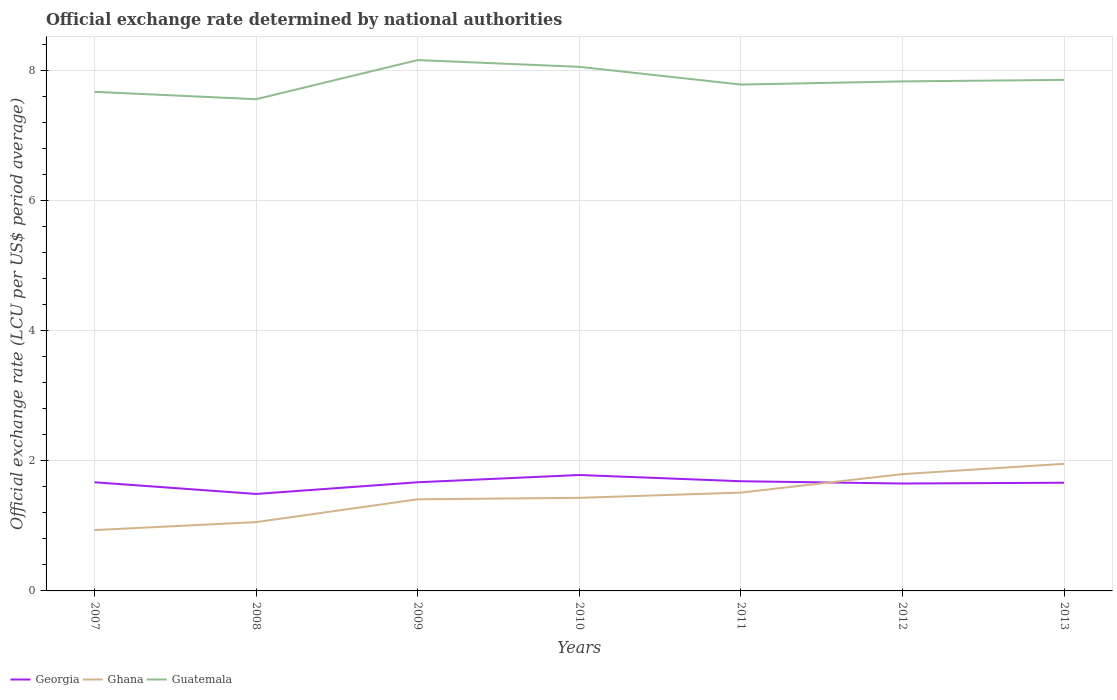How many different coloured lines are there?
Keep it short and to the point. 3. Across all years, what is the maximum official exchange rate in Georgia?
Your answer should be compact. 1.49. What is the total official exchange rate in Guatemala in the graph?
Give a very brief answer. -0.49. What is the difference between the highest and the second highest official exchange rate in Guatemala?
Keep it short and to the point. 0.6. How many lines are there?
Your answer should be compact. 3. How many years are there in the graph?
Keep it short and to the point. 7. Does the graph contain any zero values?
Your answer should be very brief. No. Does the graph contain grids?
Offer a terse response. Yes. How are the legend labels stacked?
Offer a terse response. Horizontal. What is the title of the graph?
Your response must be concise. Official exchange rate determined by national authorities. Does "El Salvador" appear as one of the legend labels in the graph?
Make the answer very short. No. What is the label or title of the Y-axis?
Give a very brief answer. Official exchange rate (LCU per US$ period average). What is the Official exchange rate (LCU per US$ period average) in Georgia in 2007?
Your response must be concise. 1.67. What is the Official exchange rate (LCU per US$ period average) of Ghana in 2007?
Offer a very short reply. 0.94. What is the Official exchange rate (LCU per US$ period average) of Guatemala in 2007?
Offer a terse response. 7.67. What is the Official exchange rate (LCU per US$ period average) of Georgia in 2008?
Offer a terse response. 1.49. What is the Official exchange rate (LCU per US$ period average) of Ghana in 2008?
Ensure brevity in your answer.  1.06. What is the Official exchange rate (LCU per US$ period average) of Guatemala in 2008?
Your response must be concise. 7.56. What is the Official exchange rate (LCU per US$ period average) of Georgia in 2009?
Provide a short and direct response. 1.67. What is the Official exchange rate (LCU per US$ period average) in Ghana in 2009?
Your answer should be very brief. 1.41. What is the Official exchange rate (LCU per US$ period average) of Guatemala in 2009?
Offer a very short reply. 8.16. What is the Official exchange rate (LCU per US$ period average) of Georgia in 2010?
Offer a terse response. 1.78. What is the Official exchange rate (LCU per US$ period average) in Ghana in 2010?
Provide a succinct answer. 1.43. What is the Official exchange rate (LCU per US$ period average) of Guatemala in 2010?
Make the answer very short. 8.06. What is the Official exchange rate (LCU per US$ period average) in Georgia in 2011?
Give a very brief answer. 1.69. What is the Official exchange rate (LCU per US$ period average) in Ghana in 2011?
Your response must be concise. 1.51. What is the Official exchange rate (LCU per US$ period average) in Guatemala in 2011?
Your answer should be very brief. 7.79. What is the Official exchange rate (LCU per US$ period average) of Georgia in 2012?
Make the answer very short. 1.65. What is the Official exchange rate (LCU per US$ period average) in Ghana in 2012?
Your answer should be very brief. 1.8. What is the Official exchange rate (LCU per US$ period average) in Guatemala in 2012?
Provide a short and direct response. 7.83. What is the Official exchange rate (LCU per US$ period average) in Georgia in 2013?
Make the answer very short. 1.66. What is the Official exchange rate (LCU per US$ period average) in Ghana in 2013?
Provide a short and direct response. 1.95. What is the Official exchange rate (LCU per US$ period average) of Guatemala in 2013?
Offer a very short reply. 7.86. Across all years, what is the maximum Official exchange rate (LCU per US$ period average) of Georgia?
Offer a very short reply. 1.78. Across all years, what is the maximum Official exchange rate (LCU per US$ period average) in Ghana?
Offer a terse response. 1.95. Across all years, what is the maximum Official exchange rate (LCU per US$ period average) in Guatemala?
Give a very brief answer. 8.16. Across all years, what is the minimum Official exchange rate (LCU per US$ period average) of Georgia?
Ensure brevity in your answer.  1.49. Across all years, what is the minimum Official exchange rate (LCU per US$ period average) in Ghana?
Ensure brevity in your answer.  0.94. Across all years, what is the minimum Official exchange rate (LCU per US$ period average) in Guatemala?
Offer a very short reply. 7.56. What is the total Official exchange rate (LCU per US$ period average) in Georgia in the graph?
Your answer should be compact. 11.62. What is the total Official exchange rate (LCU per US$ period average) in Ghana in the graph?
Offer a terse response. 10.09. What is the total Official exchange rate (LCU per US$ period average) of Guatemala in the graph?
Your answer should be compact. 54.93. What is the difference between the Official exchange rate (LCU per US$ period average) in Georgia in 2007 and that in 2008?
Your response must be concise. 0.18. What is the difference between the Official exchange rate (LCU per US$ period average) in Ghana in 2007 and that in 2008?
Your answer should be compact. -0.12. What is the difference between the Official exchange rate (LCU per US$ period average) in Guatemala in 2007 and that in 2008?
Your answer should be compact. 0.11. What is the difference between the Official exchange rate (LCU per US$ period average) in Georgia in 2007 and that in 2009?
Your answer should be very brief. 0. What is the difference between the Official exchange rate (LCU per US$ period average) in Ghana in 2007 and that in 2009?
Give a very brief answer. -0.47. What is the difference between the Official exchange rate (LCU per US$ period average) in Guatemala in 2007 and that in 2009?
Offer a terse response. -0.49. What is the difference between the Official exchange rate (LCU per US$ period average) in Georgia in 2007 and that in 2010?
Provide a short and direct response. -0.11. What is the difference between the Official exchange rate (LCU per US$ period average) of Ghana in 2007 and that in 2010?
Give a very brief answer. -0.5. What is the difference between the Official exchange rate (LCU per US$ period average) of Guatemala in 2007 and that in 2010?
Offer a terse response. -0.38. What is the difference between the Official exchange rate (LCU per US$ period average) of Georgia in 2007 and that in 2011?
Your answer should be compact. -0.02. What is the difference between the Official exchange rate (LCU per US$ period average) of Ghana in 2007 and that in 2011?
Your response must be concise. -0.58. What is the difference between the Official exchange rate (LCU per US$ period average) of Guatemala in 2007 and that in 2011?
Give a very brief answer. -0.11. What is the difference between the Official exchange rate (LCU per US$ period average) in Georgia in 2007 and that in 2012?
Make the answer very short. 0.02. What is the difference between the Official exchange rate (LCU per US$ period average) of Ghana in 2007 and that in 2012?
Ensure brevity in your answer.  -0.86. What is the difference between the Official exchange rate (LCU per US$ period average) of Guatemala in 2007 and that in 2012?
Ensure brevity in your answer.  -0.16. What is the difference between the Official exchange rate (LCU per US$ period average) in Georgia in 2007 and that in 2013?
Your answer should be compact. 0.01. What is the difference between the Official exchange rate (LCU per US$ period average) in Ghana in 2007 and that in 2013?
Provide a succinct answer. -1.02. What is the difference between the Official exchange rate (LCU per US$ period average) of Guatemala in 2007 and that in 2013?
Make the answer very short. -0.18. What is the difference between the Official exchange rate (LCU per US$ period average) of Georgia in 2008 and that in 2009?
Offer a very short reply. -0.18. What is the difference between the Official exchange rate (LCU per US$ period average) of Ghana in 2008 and that in 2009?
Offer a terse response. -0.35. What is the difference between the Official exchange rate (LCU per US$ period average) of Guatemala in 2008 and that in 2009?
Keep it short and to the point. -0.6. What is the difference between the Official exchange rate (LCU per US$ period average) in Georgia in 2008 and that in 2010?
Make the answer very short. -0.29. What is the difference between the Official exchange rate (LCU per US$ period average) in Ghana in 2008 and that in 2010?
Give a very brief answer. -0.37. What is the difference between the Official exchange rate (LCU per US$ period average) of Guatemala in 2008 and that in 2010?
Your answer should be very brief. -0.5. What is the difference between the Official exchange rate (LCU per US$ period average) in Georgia in 2008 and that in 2011?
Keep it short and to the point. -0.2. What is the difference between the Official exchange rate (LCU per US$ period average) of Ghana in 2008 and that in 2011?
Make the answer very short. -0.45. What is the difference between the Official exchange rate (LCU per US$ period average) in Guatemala in 2008 and that in 2011?
Your answer should be very brief. -0.23. What is the difference between the Official exchange rate (LCU per US$ period average) of Georgia in 2008 and that in 2012?
Provide a short and direct response. -0.16. What is the difference between the Official exchange rate (LCU per US$ period average) in Ghana in 2008 and that in 2012?
Provide a succinct answer. -0.74. What is the difference between the Official exchange rate (LCU per US$ period average) in Guatemala in 2008 and that in 2012?
Your response must be concise. -0.27. What is the difference between the Official exchange rate (LCU per US$ period average) in Georgia in 2008 and that in 2013?
Your answer should be compact. -0.17. What is the difference between the Official exchange rate (LCU per US$ period average) of Ghana in 2008 and that in 2013?
Provide a short and direct response. -0.9. What is the difference between the Official exchange rate (LCU per US$ period average) in Guatemala in 2008 and that in 2013?
Offer a terse response. -0.3. What is the difference between the Official exchange rate (LCU per US$ period average) in Georgia in 2009 and that in 2010?
Offer a terse response. -0.11. What is the difference between the Official exchange rate (LCU per US$ period average) in Ghana in 2009 and that in 2010?
Your answer should be compact. -0.02. What is the difference between the Official exchange rate (LCU per US$ period average) in Guatemala in 2009 and that in 2010?
Keep it short and to the point. 0.1. What is the difference between the Official exchange rate (LCU per US$ period average) in Georgia in 2009 and that in 2011?
Provide a succinct answer. -0.02. What is the difference between the Official exchange rate (LCU per US$ period average) of Ghana in 2009 and that in 2011?
Your answer should be compact. -0.1. What is the difference between the Official exchange rate (LCU per US$ period average) in Guatemala in 2009 and that in 2011?
Give a very brief answer. 0.38. What is the difference between the Official exchange rate (LCU per US$ period average) in Georgia in 2009 and that in 2012?
Give a very brief answer. 0.02. What is the difference between the Official exchange rate (LCU per US$ period average) in Ghana in 2009 and that in 2012?
Make the answer very short. -0.39. What is the difference between the Official exchange rate (LCU per US$ period average) of Guatemala in 2009 and that in 2012?
Keep it short and to the point. 0.33. What is the difference between the Official exchange rate (LCU per US$ period average) in Georgia in 2009 and that in 2013?
Provide a succinct answer. 0.01. What is the difference between the Official exchange rate (LCU per US$ period average) of Ghana in 2009 and that in 2013?
Offer a very short reply. -0.55. What is the difference between the Official exchange rate (LCU per US$ period average) of Guatemala in 2009 and that in 2013?
Provide a short and direct response. 0.3. What is the difference between the Official exchange rate (LCU per US$ period average) of Georgia in 2010 and that in 2011?
Provide a succinct answer. 0.1. What is the difference between the Official exchange rate (LCU per US$ period average) in Ghana in 2010 and that in 2011?
Provide a succinct answer. -0.08. What is the difference between the Official exchange rate (LCU per US$ period average) in Guatemala in 2010 and that in 2011?
Provide a short and direct response. 0.27. What is the difference between the Official exchange rate (LCU per US$ period average) in Georgia in 2010 and that in 2012?
Make the answer very short. 0.13. What is the difference between the Official exchange rate (LCU per US$ period average) of Ghana in 2010 and that in 2012?
Your response must be concise. -0.36. What is the difference between the Official exchange rate (LCU per US$ period average) of Guatemala in 2010 and that in 2012?
Offer a very short reply. 0.22. What is the difference between the Official exchange rate (LCU per US$ period average) of Georgia in 2010 and that in 2013?
Offer a terse response. 0.12. What is the difference between the Official exchange rate (LCU per US$ period average) in Ghana in 2010 and that in 2013?
Offer a terse response. -0.52. What is the difference between the Official exchange rate (LCU per US$ period average) of Guatemala in 2010 and that in 2013?
Offer a terse response. 0.2. What is the difference between the Official exchange rate (LCU per US$ period average) in Georgia in 2011 and that in 2012?
Your response must be concise. 0.04. What is the difference between the Official exchange rate (LCU per US$ period average) in Ghana in 2011 and that in 2012?
Your answer should be compact. -0.28. What is the difference between the Official exchange rate (LCU per US$ period average) of Guatemala in 2011 and that in 2012?
Make the answer very short. -0.05. What is the difference between the Official exchange rate (LCU per US$ period average) in Georgia in 2011 and that in 2013?
Offer a very short reply. 0.02. What is the difference between the Official exchange rate (LCU per US$ period average) in Ghana in 2011 and that in 2013?
Make the answer very short. -0.44. What is the difference between the Official exchange rate (LCU per US$ period average) in Guatemala in 2011 and that in 2013?
Ensure brevity in your answer.  -0.07. What is the difference between the Official exchange rate (LCU per US$ period average) in Georgia in 2012 and that in 2013?
Provide a succinct answer. -0.01. What is the difference between the Official exchange rate (LCU per US$ period average) in Ghana in 2012 and that in 2013?
Ensure brevity in your answer.  -0.16. What is the difference between the Official exchange rate (LCU per US$ period average) in Guatemala in 2012 and that in 2013?
Offer a very short reply. -0.02. What is the difference between the Official exchange rate (LCU per US$ period average) of Georgia in 2007 and the Official exchange rate (LCU per US$ period average) of Ghana in 2008?
Provide a succinct answer. 0.61. What is the difference between the Official exchange rate (LCU per US$ period average) in Georgia in 2007 and the Official exchange rate (LCU per US$ period average) in Guatemala in 2008?
Make the answer very short. -5.89. What is the difference between the Official exchange rate (LCU per US$ period average) in Ghana in 2007 and the Official exchange rate (LCU per US$ period average) in Guatemala in 2008?
Keep it short and to the point. -6.62. What is the difference between the Official exchange rate (LCU per US$ period average) in Georgia in 2007 and the Official exchange rate (LCU per US$ period average) in Ghana in 2009?
Offer a very short reply. 0.26. What is the difference between the Official exchange rate (LCU per US$ period average) in Georgia in 2007 and the Official exchange rate (LCU per US$ period average) in Guatemala in 2009?
Make the answer very short. -6.49. What is the difference between the Official exchange rate (LCU per US$ period average) in Ghana in 2007 and the Official exchange rate (LCU per US$ period average) in Guatemala in 2009?
Provide a short and direct response. -7.23. What is the difference between the Official exchange rate (LCU per US$ period average) in Georgia in 2007 and the Official exchange rate (LCU per US$ period average) in Ghana in 2010?
Provide a succinct answer. 0.24. What is the difference between the Official exchange rate (LCU per US$ period average) of Georgia in 2007 and the Official exchange rate (LCU per US$ period average) of Guatemala in 2010?
Provide a succinct answer. -6.39. What is the difference between the Official exchange rate (LCU per US$ period average) of Ghana in 2007 and the Official exchange rate (LCU per US$ period average) of Guatemala in 2010?
Offer a terse response. -7.12. What is the difference between the Official exchange rate (LCU per US$ period average) of Georgia in 2007 and the Official exchange rate (LCU per US$ period average) of Ghana in 2011?
Your answer should be very brief. 0.16. What is the difference between the Official exchange rate (LCU per US$ period average) of Georgia in 2007 and the Official exchange rate (LCU per US$ period average) of Guatemala in 2011?
Your answer should be very brief. -6.11. What is the difference between the Official exchange rate (LCU per US$ period average) of Ghana in 2007 and the Official exchange rate (LCU per US$ period average) of Guatemala in 2011?
Your answer should be very brief. -6.85. What is the difference between the Official exchange rate (LCU per US$ period average) of Georgia in 2007 and the Official exchange rate (LCU per US$ period average) of Ghana in 2012?
Your answer should be very brief. -0.13. What is the difference between the Official exchange rate (LCU per US$ period average) in Georgia in 2007 and the Official exchange rate (LCU per US$ period average) in Guatemala in 2012?
Your answer should be compact. -6.16. What is the difference between the Official exchange rate (LCU per US$ period average) in Ghana in 2007 and the Official exchange rate (LCU per US$ period average) in Guatemala in 2012?
Offer a terse response. -6.9. What is the difference between the Official exchange rate (LCU per US$ period average) in Georgia in 2007 and the Official exchange rate (LCU per US$ period average) in Ghana in 2013?
Offer a terse response. -0.28. What is the difference between the Official exchange rate (LCU per US$ period average) in Georgia in 2007 and the Official exchange rate (LCU per US$ period average) in Guatemala in 2013?
Make the answer very short. -6.19. What is the difference between the Official exchange rate (LCU per US$ period average) in Ghana in 2007 and the Official exchange rate (LCU per US$ period average) in Guatemala in 2013?
Your answer should be compact. -6.92. What is the difference between the Official exchange rate (LCU per US$ period average) of Georgia in 2008 and the Official exchange rate (LCU per US$ period average) of Ghana in 2009?
Keep it short and to the point. 0.08. What is the difference between the Official exchange rate (LCU per US$ period average) in Georgia in 2008 and the Official exchange rate (LCU per US$ period average) in Guatemala in 2009?
Make the answer very short. -6.67. What is the difference between the Official exchange rate (LCU per US$ period average) of Ghana in 2008 and the Official exchange rate (LCU per US$ period average) of Guatemala in 2009?
Offer a very short reply. -7.1. What is the difference between the Official exchange rate (LCU per US$ period average) of Georgia in 2008 and the Official exchange rate (LCU per US$ period average) of Ghana in 2010?
Give a very brief answer. 0.06. What is the difference between the Official exchange rate (LCU per US$ period average) of Georgia in 2008 and the Official exchange rate (LCU per US$ period average) of Guatemala in 2010?
Your response must be concise. -6.57. What is the difference between the Official exchange rate (LCU per US$ period average) in Ghana in 2008 and the Official exchange rate (LCU per US$ period average) in Guatemala in 2010?
Provide a short and direct response. -7. What is the difference between the Official exchange rate (LCU per US$ period average) of Georgia in 2008 and the Official exchange rate (LCU per US$ period average) of Ghana in 2011?
Give a very brief answer. -0.02. What is the difference between the Official exchange rate (LCU per US$ period average) in Georgia in 2008 and the Official exchange rate (LCU per US$ period average) in Guatemala in 2011?
Make the answer very short. -6.29. What is the difference between the Official exchange rate (LCU per US$ period average) in Ghana in 2008 and the Official exchange rate (LCU per US$ period average) in Guatemala in 2011?
Your response must be concise. -6.73. What is the difference between the Official exchange rate (LCU per US$ period average) of Georgia in 2008 and the Official exchange rate (LCU per US$ period average) of Ghana in 2012?
Offer a terse response. -0.3. What is the difference between the Official exchange rate (LCU per US$ period average) of Georgia in 2008 and the Official exchange rate (LCU per US$ period average) of Guatemala in 2012?
Make the answer very short. -6.34. What is the difference between the Official exchange rate (LCU per US$ period average) of Ghana in 2008 and the Official exchange rate (LCU per US$ period average) of Guatemala in 2012?
Your answer should be very brief. -6.78. What is the difference between the Official exchange rate (LCU per US$ period average) of Georgia in 2008 and the Official exchange rate (LCU per US$ period average) of Ghana in 2013?
Offer a terse response. -0.46. What is the difference between the Official exchange rate (LCU per US$ period average) of Georgia in 2008 and the Official exchange rate (LCU per US$ period average) of Guatemala in 2013?
Offer a terse response. -6.37. What is the difference between the Official exchange rate (LCU per US$ period average) of Ghana in 2008 and the Official exchange rate (LCU per US$ period average) of Guatemala in 2013?
Keep it short and to the point. -6.8. What is the difference between the Official exchange rate (LCU per US$ period average) of Georgia in 2009 and the Official exchange rate (LCU per US$ period average) of Ghana in 2010?
Provide a short and direct response. 0.24. What is the difference between the Official exchange rate (LCU per US$ period average) of Georgia in 2009 and the Official exchange rate (LCU per US$ period average) of Guatemala in 2010?
Your answer should be very brief. -6.39. What is the difference between the Official exchange rate (LCU per US$ period average) in Ghana in 2009 and the Official exchange rate (LCU per US$ period average) in Guatemala in 2010?
Provide a succinct answer. -6.65. What is the difference between the Official exchange rate (LCU per US$ period average) of Georgia in 2009 and the Official exchange rate (LCU per US$ period average) of Ghana in 2011?
Offer a very short reply. 0.16. What is the difference between the Official exchange rate (LCU per US$ period average) of Georgia in 2009 and the Official exchange rate (LCU per US$ period average) of Guatemala in 2011?
Your response must be concise. -6.11. What is the difference between the Official exchange rate (LCU per US$ period average) in Ghana in 2009 and the Official exchange rate (LCU per US$ period average) in Guatemala in 2011?
Your answer should be very brief. -6.38. What is the difference between the Official exchange rate (LCU per US$ period average) in Georgia in 2009 and the Official exchange rate (LCU per US$ period average) in Ghana in 2012?
Your response must be concise. -0.13. What is the difference between the Official exchange rate (LCU per US$ period average) of Georgia in 2009 and the Official exchange rate (LCU per US$ period average) of Guatemala in 2012?
Your answer should be very brief. -6.16. What is the difference between the Official exchange rate (LCU per US$ period average) in Ghana in 2009 and the Official exchange rate (LCU per US$ period average) in Guatemala in 2012?
Offer a terse response. -6.42. What is the difference between the Official exchange rate (LCU per US$ period average) of Georgia in 2009 and the Official exchange rate (LCU per US$ period average) of Ghana in 2013?
Make the answer very short. -0.28. What is the difference between the Official exchange rate (LCU per US$ period average) of Georgia in 2009 and the Official exchange rate (LCU per US$ period average) of Guatemala in 2013?
Keep it short and to the point. -6.19. What is the difference between the Official exchange rate (LCU per US$ period average) of Ghana in 2009 and the Official exchange rate (LCU per US$ period average) of Guatemala in 2013?
Provide a short and direct response. -6.45. What is the difference between the Official exchange rate (LCU per US$ period average) of Georgia in 2010 and the Official exchange rate (LCU per US$ period average) of Ghana in 2011?
Your answer should be compact. 0.27. What is the difference between the Official exchange rate (LCU per US$ period average) in Georgia in 2010 and the Official exchange rate (LCU per US$ period average) in Guatemala in 2011?
Your response must be concise. -6. What is the difference between the Official exchange rate (LCU per US$ period average) of Ghana in 2010 and the Official exchange rate (LCU per US$ period average) of Guatemala in 2011?
Your answer should be compact. -6.35. What is the difference between the Official exchange rate (LCU per US$ period average) of Georgia in 2010 and the Official exchange rate (LCU per US$ period average) of Ghana in 2012?
Your response must be concise. -0.01. What is the difference between the Official exchange rate (LCU per US$ period average) in Georgia in 2010 and the Official exchange rate (LCU per US$ period average) in Guatemala in 2012?
Provide a succinct answer. -6.05. What is the difference between the Official exchange rate (LCU per US$ period average) of Ghana in 2010 and the Official exchange rate (LCU per US$ period average) of Guatemala in 2012?
Offer a very short reply. -6.4. What is the difference between the Official exchange rate (LCU per US$ period average) of Georgia in 2010 and the Official exchange rate (LCU per US$ period average) of Ghana in 2013?
Your response must be concise. -0.17. What is the difference between the Official exchange rate (LCU per US$ period average) of Georgia in 2010 and the Official exchange rate (LCU per US$ period average) of Guatemala in 2013?
Make the answer very short. -6.07. What is the difference between the Official exchange rate (LCU per US$ period average) in Ghana in 2010 and the Official exchange rate (LCU per US$ period average) in Guatemala in 2013?
Your answer should be compact. -6.43. What is the difference between the Official exchange rate (LCU per US$ period average) in Georgia in 2011 and the Official exchange rate (LCU per US$ period average) in Ghana in 2012?
Your answer should be compact. -0.11. What is the difference between the Official exchange rate (LCU per US$ period average) in Georgia in 2011 and the Official exchange rate (LCU per US$ period average) in Guatemala in 2012?
Offer a terse response. -6.15. What is the difference between the Official exchange rate (LCU per US$ period average) in Ghana in 2011 and the Official exchange rate (LCU per US$ period average) in Guatemala in 2012?
Provide a succinct answer. -6.32. What is the difference between the Official exchange rate (LCU per US$ period average) of Georgia in 2011 and the Official exchange rate (LCU per US$ period average) of Ghana in 2013?
Provide a short and direct response. -0.27. What is the difference between the Official exchange rate (LCU per US$ period average) in Georgia in 2011 and the Official exchange rate (LCU per US$ period average) in Guatemala in 2013?
Your answer should be compact. -6.17. What is the difference between the Official exchange rate (LCU per US$ period average) in Ghana in 2011 and the Official exchange rate (LCU per US$ period average) in Guatemala in 2013?
Offer a terse response. -6.34. What is the difference between the Official exchange rate (LCU per US$ period average) in Georgia in 2012 and the Official exchange rate (LCU per US$ period average) in Ghana in 2013?
Offer a very short reply. -0.3. What is the difference between the Official exchange rate (LCU per US$ period average) of Georgia in 2012 and the Official exchange rate (LCU per US$ period average) of Guatemala in 2013?
Offer a terse response. -6.21. What is the difference between the Official exchange rate (LCU per US$ period average) of Ghana in 2012 and the Official exchange rate (LCU per US$ period average) of Guatemala in 2013?
Offer a terse response. -6.06. What is the average Official exchange rate (LCU per US$ period average) in Georgia per year?
Your answer should be compact. 1.66. What is the average Official exchange rate (LCU per US$ period average) of Ghana per year?
Provide a short and direct response. 1.44. What is the average Official exchange rate (LCU per US$ period average) in Guatemala per year?
Ensure brevity in your answer.  7.85. In the year 2007, what is the difference between the Official exchange rate (LCU per US$ period average) of Georgia and Official exchange rate (LCU per US$ period average) of Ghana?
Your response must be concise. 0.74. In the year 2007, what is the difference between the Official exchange rate (LCU per US$ period average) in Georgia and Official exchange rate (LCU per US$ period average) in Guatemala?
Give a very brief answer. -6. In the year 2007, what is the difference between the Official exchange rate (LCU per US$ period average) in Ghana and Official exchange rate (LCU per US$ period average) in Guatemala?
Provide a succinct answer. -6.74. In the year 2008, what is the difference between the Official exchange rate (LCU per US$ period average) in Georgia and Official exchange rate (LCU per US$ period average) in Ghana?
Offer a terse response. 0.43. In the year 2008, what is the difference between the Official exchange rate (LCU per US$ period average) in Georgia and Official exchange rate (LCU per US$ period average) in Guatemala?
Keep it short and to the point. -6.07. In the year 2008, what is the difference between the Official exchange rate (LCU per US$ period average) of Ghana and Official exchange rate (LCU per US$ period average) of Guatemala?
Keep it short and to the point. -6.5. In the year 2009, what is the difference between the Official exchange rate (LCU per US$ period average) of Georgia and Official exchange rate (LCU per US$ period average) of Ghana?
Your answer should be compact. 0.26. In the year 2009, what is the difference between the Official exchange rate (LCU per US$ period average) in Georgia and Official exchange rate (LCU per US$ period average) in Guatemala?
Give a very brief answer. -6.49. In the year 2009, what is the difference between the Official exchange rate (LCU per US$ period average) of Ghana and Official exchange rate (LCU per US$ period average) of Guatemala?
Offer a very short reply. -6.75. In the year 2010, what is the difference between the Official exchange rate (LCU per US$ period average) in Georgia and Official exchange rate (LCU per US$ period average) in Ghana?
Your response must be concise. 0.35. In the year 2010, what is the difference between the Official exchange rate (LCU per US$ period average) of Georgia and Official exchange rate (LCU per US$ period average) of Guatemala?
Offer a very short reply. -6.28. In the year 2010, what is the difference between the Official exchange rate (LCU per US$ period average) in Ghana and Official exchange rate (LCU per US$ period average) in Guatemala?
Your answer should be very brief. -6.63. In the year 2011, what is the difference between the Official exchange rate (LCU per US$ period average) of Georgia and Official exchange rate (LCU per US$ period average) of Ghana?
Your answer should be very brief. 0.17. In the year 2011, what is the difference between the Official exchange rate (LCU per US$ period average) in Georgia and Official exchange rate (LCU per US$ period average) in Guatemala?
Provide a succinct answer. -6.1. In the year 2011, what is the difference between the Official exchange rate (LCU per US$ period average) in Ghana and Official exchange rate (LCU per US$ period average) in Guatemala?
Keep it short and to the point. -6.27. In the year 2012, what is the difference between the Official exchange rate (LCU per US$ period average) of Georgia and Official exchange rate (LCU per US$ period average) of Ghana?
Ensure brevity in your answer.  -0.14. In the year 2012, what is the difference between the Official exchange rate (LCU per US$ period average) of Georgia and Official exchange rate (LCU per US$ period average) of Guatemala?
Your response must be concise. -6.18. In the year 2012, what is the difference between the Official exchange rate (LCU per US$ period average) of Ghana and Official exchange rate (LCU per US$ period average) of Guatemala?
Your answer should be compact. -6.04. In the year 2013, what is the difference between the Official exchange rate (LCU per US$ period average) of Georgia and Official exchange rate (LCU per US$ period average) of Ghana?
Offer a terse response. -0.29. In the year 2013, what is the difference between the Official exchange rate (LCU per US$ period average) of Georgia and Official exchange rate (LCU per US$ period average) of Guatemala?
Your response must be concise. -6.19. In the year 2013, what is the difference between the Official exchange rate (LCU per US$ period average) of Ghana and Official exchange rate (LCU per US$ period average) of Guatemala?
Ensure brevity in your answer.  -5.9. What is the ratio of the Official exchange rate (LCU per US$ period average) of Georgia in 2007 to that in 2008?
Provide a succinct answer. 1.12. What is the ratio of the Official exchange rate (LCU per US$ period average) in Ghana in 2007 to that in 2008?
Your answer should be very brief. 0.88. What is the ratio of the Official exchange rate (LCU per US$ period average) in Guatemala in 2007 to that in 2008?
Your response must be concise. 1.01. What is the ratio of the Official exchange rate (LCU per US$ period average) in Ghana in 2007 to that in 2009?
Your answer should be compact. 0.66. What is the ratio of the Official exchange rate (LCU per US$ period average) of Guatemala in 2007 to that in 2009?
Provide a succinct answer. 0.94. What is the ratio of the Official exchange rate (LCU per US$ period average) in Georgia in 2007 to that in 2010?
Keep it short and to the point. 0.94. What is the ratio of the Official exchange rate (LCU per US$ period average) in Ghana in 2007 to that in 2010?
Make the answer very short. 0.65. What is the ratio of the Official exchange rate (LCU per US$ period average) in Guatemala in 2007 to that in 2010?
Provide a short and direct response. 0.95. What is the ratio of the Official exchange rate (LCU per US$ period average) in Ghana in 2007 to that in 2011?
Your answer should be compact. 0.62. What is the ratio of the Official exchange rate (LCU per US$ period average) in Guatemala in 2007 to that in 2011?
Offer a very short reply. 0.99. What is the ratio of the Official exchange rate (LCU per US$ period average) in Georgia in 2007 to that in 2012?
Provide a short and direct response. 1.01. What is the ratio of the Official exchange rate (LCU per US$ period average) in Ghana in 2007 to that in 2012?
Your answer should be very brief. 0.52. What is the ratio of the Official exchange rate (LCU per US$ period average) in Guatemala in 2007 to that in 2012?
Give a very brief answer. 0.98. What is the ratio of the Official exchange rate (LCU per US$ period average) in Georgia in 2007 to that in 2013?
Keep it short and to the point. 1. What is the ratio of the Official exchange rate (LCU per US$ period average) of Ghana in 2007 to that in 2013?
Offer a very short reply. 0.48. What is the ratio of the Official exchange rate (LCU per US$ period average) of Guatemala in 2007 to that in 2013?
Provide a succinct answer. 0.98. What is the ratio of the Official exchange rate (LCU per US$ period average) of Georgia in 2008 to that in 2009?
Your answer should be very brief. 0.89. What is the ratio of the Official exchange rate (LCU per US$ period average) of Ghana in 2008 to that in 2009?
Keep it short and to the point. 0.75. What is the ratio of the Official exchange rate (LCU per US$ period average) in Guatemala in 2008 to that in 2009?
Give a very brief answer. 0.93. What is the ratio of the Official exchange rate (LCU per US$ period average) in Georgia in 2008 to that in 2010?
Ensure brevity in your answer.  0.84. What is the ratio of the Official exchange rate (LCU per US$ period average) in Ghana in 2008 to that in 2010?
Your answer should be compact. 0.74. What is the ratio of the Official exchange rate (LCU per US$ period average) in Guatemala in 2008 to that in 2010?
Your answer should be very brief. 0.94. What is the ratio of the Official exchange rate (LCU per US$ period average) of Georgia in 2008 to that in 2011?
Your answer should be compact. 0.88. What is the ratio of the Official exchange rate (LCU per US$ period average) in Ghana in 2008 to that in 2011?
Give a very brief answer. 0.7. What is the ratio of the Official exchange rate (LCU per US$ period average) in Georgia in 2008 to that in 2012?
Your answer should be compact. 0.9. What is the ratio of the Official exchange rate (LCU per US$ period average) of Ghana in 2008 to that in 2012?
Your answer should be compact. 0.59. What is the ratio of the Official exchange rate (LCU per US$ period average) of Guatemala in 2008 to that in 2012?
Make the answer very short. 0.97. What is the ratio of the Official exchange rate (LCU per US$ period average) in Georgia in 2008 to that in 2013?
Your answer should be very brief. 0.9. What is the ratio of the Official exchange rate (LCU per US$ period average) of Ghana in 2008 to that in 2013?
Offer a very short reply. 0.54. What is the ratio of the Official exchange rate (LCU per US$ period average) of Guatemala in 2008 to that in 2013?
Provide a short and direct response. 0.96. What is the ratio of the Official exchange rate (LCU per US$ period average) of Georgia in 2009 to that in 2010?
Keep it short and to the point. 0.94. What is the ratio of the Official exchange rate (LCU per US$ period average) of Ghana in 2009 to that in 2010?
Your answer should be very brief. 0.98. What is the ratio of the Official exchange rate (LCU per US$ period average) in Guatemala in 2009 to that in 2010?
Offer a very short reply. 1.01. What is the ratio of the Official exchange rate (LCU per US$ period average) of Ghana in 2009 to that in 2011?
Your response must be concise. 0.93. What is the ratio of the Official exchange rate (LCU per US$ period average) of Guatemala in 2009 to that in 2011?
Provide a short and direct response. 1.05. What is the ratio of the Official exchange rate (LCU per US$ period average) in Georgia in 2009 to that in 2012?
Your response must be concise. 1.01. What is the ratio of the Official exchange rate (LCU per US$ period average) in Ghana in 2009 to that in 2012?
Offer a very short reply. 0.78. What is the ratio of the Official exchange rate (LCU per US$ period average) in Guatemala in 2009 to that in 2012?
Make the answer very short. 1.04. What is the ratio of the Official exchange rate (LCU per US$ period average) of Ghana in 2009 to that in 2013?
Make the answer very short. 0.72. What is the ratio of the Official exchange rate (LCU per US$ period average) of Guatemala in 2009 to that in 2013?
Provide a succinct answer. 1.04. What is the ratio of the Official exchange rate (LCU per US$ period average) of Georgia in 2010 to that in 2011?
Ensure brevity in your answer.  1.06. What is the ratio of the Official exchange rate (LCU per US$ period average) in Ghana in 2010 to that in 2011?
Your answer should be compact. 0.95. What is the ratio of the Official exchange rate (LCU per US$ period average) of Guatemala in 2010 to that in 2011?
Make the answer very short. 1.03. What is the ratio of the Official exchange rate (LCU per US$ period average) of Georgia in 2010 to that in 2012?
Keep it short and to the point. 1.08. What is the ratio of the Official exchange rate (LCU per US$ period average) of Ghana in 2010 to that in 2012?
Offer a terse response. 0.8. What is the ratio of the Official exchange rate (LCU per US$ period average) in Guatemala in 2010 to that in 2012?
Ensure brevity in your answer.  1.03. What is the ratio of the Official exchange rate (LCU per US$ period average) in Georgia in 2010 to that in 2013?
Your answer should be very brief. 1.07. What is the ratio of the Official exchange rate (LCU per US$ period average) of Ghana in 2010 to that in 2013?
Offer a very short reply. 0.73. What is the ratio of the Official exchange rate (LCU per US$ period average) of Guatemala in 2010 to that in 2013?
Offer a very short reply. 1.03. What is the ratio of the Official exchange rate (LCU per US$ period average) of Georgia in 2011 to that in 2012?
Offer a terse response. 1.02. What is the ratio of the Official exchange rate (LCU per US$ period average) in Ghana in 2011 to that in 2012?
Keep it short and to the point. 0.84. What is the ratio of the Official exchange rate (LCU per US$ period average) of Guatemala in 2011 to that in 2012?
Offer a terse response. 0.99. What is the ratio of the Official exchange rate (LCU per US$ period average) in Georgia in 2011 to that in 2013?
Your response must be concise. 1.01. What is the ratio of the Official exchange rate (LCU per US$ period average) in Ghana in 2011 to that in 2013?
Make the answer very short. 0.77. What is the ratio of the Official exchange rate (LCU per US$ period average) in Guatemala in 2011 to that in 2013?
Your response must be concise. 0.99. What is the ratio of the Official exchange rate (LCU per US$ period average) of Ghana in 2012 to that in 2013?
Provide a short and direct response. 0.92. What is the ratio of the Official exchange rate (LCU per US$ period average) of Guatemala in 2012 to that in 2013?
Provide a short and direct response. 1. What is the difference between the highest and the second highest Official exchange rate (LCU per US$ period average) of Georgia?
Make the answer very short. 0.1. What is the difference between the highest and the second highest Official exchange rate (LCU per US$ period average) of Ghana?
Provide a succinct answer. 0.16. What is the difference between the highest and the second highest Official exchange rate (LCU per US$ period average) of Guatemala?
Offer a terse response. 0.1. What is the difference between the highest and the lowest Official exchange rate (LCU per US$ period average) in Georgia?
Keep it short and to the point. 0.29. What is the difference between the highest and the lowest Official exchange rate (LCU per US$ period average) of Ghana?
Make the answer very short. 1.02. What is the difference between the highest and the lowest Official exchange rate (LCU per US$ period average) in Guatemala?
Ensure brevity in your answer.  0.6. 